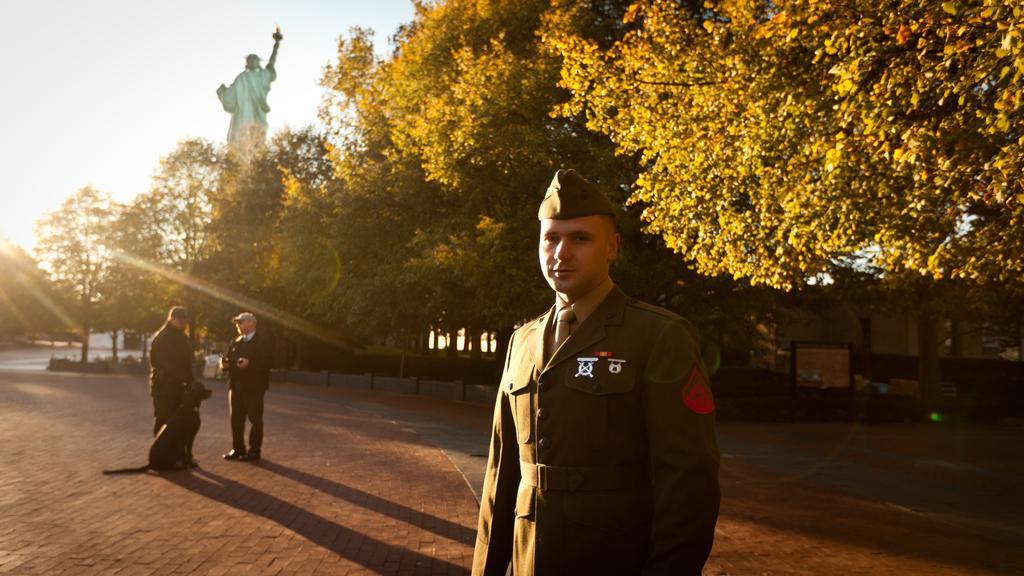Can you describe this image briefly? In this image I can see three persons are standing and in the front I can see one of them is wearing uniform. On the left side of this image I can see a dog is sitting. In the background I can see number of trees and the Statue of Liberty. I can also see few boards on the right side. 